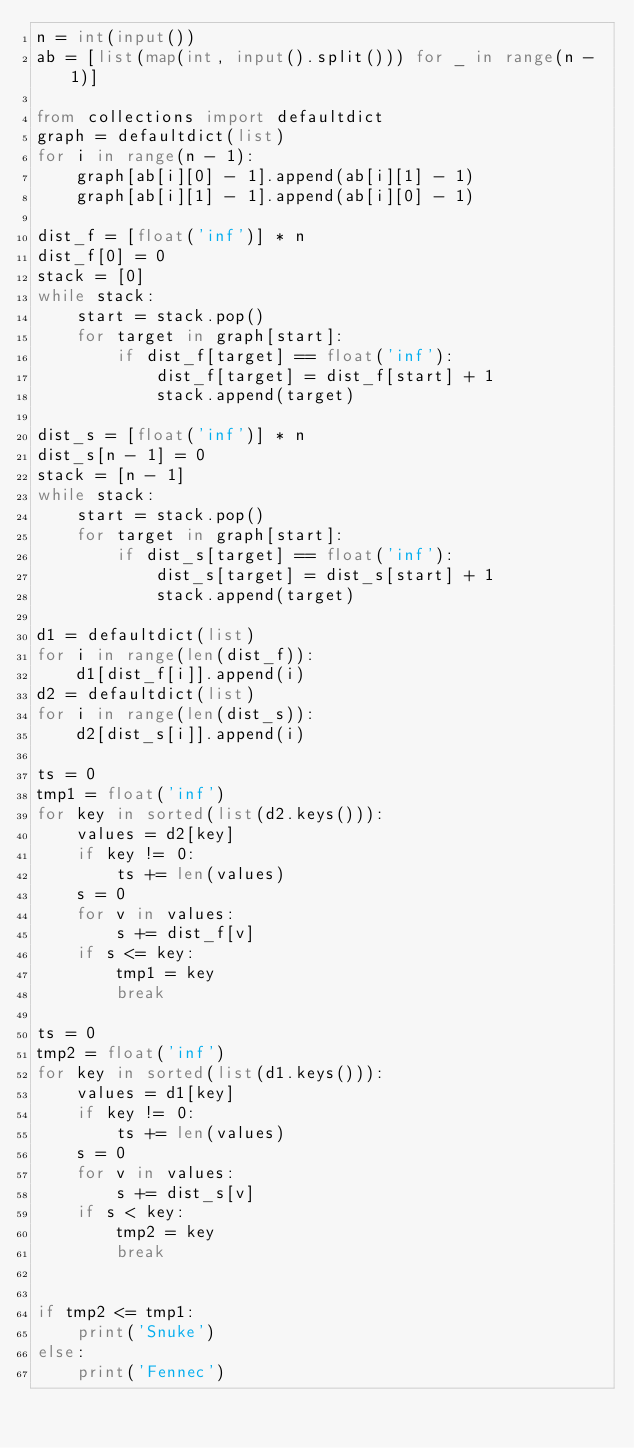<code> <loc_0><loc_0><loc_500><loc_500><_Python_>n = int(input())
ab = [list(map(int, input().split())) for _ in range(n - 1)]

from collections import defaultdict
graph = defaultdict(list)
for i in range(n - 1):
    graph[ab[i][0] - 1].append(ab[i][1] - 1)
    graph[ab[i][1] - 1].append(ab[i][0] - 1)

dist_f = [float('inf')] * n
dist_f[0] = 0
stack = [0]
while stack:
    start = stack.pop()
    for target in graph[start]:
        if dist_f[target] == float('inf'):
            dist_f[target] = dist_f[start] + 1
            stack.append(target)

dist_s = [float('inf')] * n
dist_s[n - 1] = 0
stack = [n - 1]
while stack:
    start = stack.pop()
    for target in graph[start]:
        if dist_s[target] == float('inf'):
            dist_s[target] = dist_s[start] + 1
            stack.append(target)

d1 = defaultdict(list)
for i in range(len(dist_f)):
    d1[dist_f[i]].append(i)
d2 = defaultdict(list)
for i in range(len(dist_s)):
    d2[dist_s[i]].append(i)

ts = 0
tmp1 = float('inf')
for key in sorted(list(d2.keys())):
    values = d2[key]
    if key != 0:
        ts += len(values)
    s = 0
    for v in values:
        s += dist_f[v]
    if s <= key:
        tmp1 = key
        break

ts = 0
tmp2 = float('inf')
for key in sorted(list(d1.keys())):
    values = d1[key]
    if key != 0:
        ts += len(values)
    s = 0
    for v in values:
        s += dist_s[v]
    if s < key:
        tmp2 = key
        break


if tmp2 <= tmp1:
    print('Snuke')
else:
    print('Fennec')
</code> 